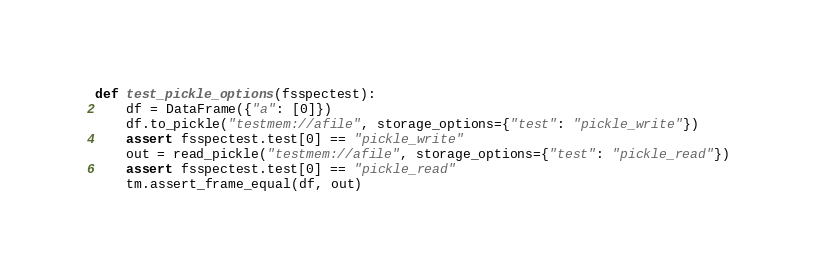<code> <loc_0><loc_0><loc_500><loc_500><_Python_>def test_pickle_options(fsspectest):
    df = DataFrame({"a": [0]})
    df.to_pickle("testmem://afile", storage_options={"test": "pickle_write"})
    assert fsspectest.test[0] == "pickle_write"
    out = read_pickle("testmem://afile", storage_options={"test": "pickle_read"})
    assert fsspectest.test[0] == "pickle_read"
    tm.assert_frame_equal(df, out)

</code> 